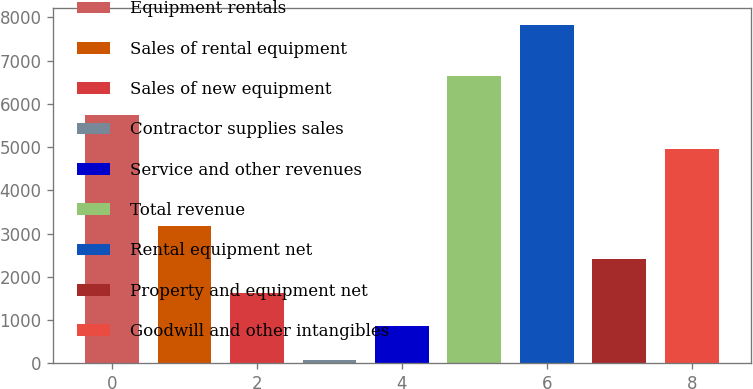Convert chart to OTSL. <chart><loc_0><loc_0><loc_500><loc_500><bar_chart><fcel>Equipment rentals<fcel>Sales of rental equipment<fcel>Sales of new equipment<fcel>Contractor supplies sales<fcel>Service and other revenues<fcel>Total revenue<fcel>Rental equipment net<fcel>Property and equipment net<fcel>Goodwill and other intangibles<nl><fcel>5731.4<fcel>3177.6<fcel>1628.8<fcel>80<fcel>854.4<fcel>6641<fcel>7824<fcel>2403.2<fcel>4957<nl></chart> 